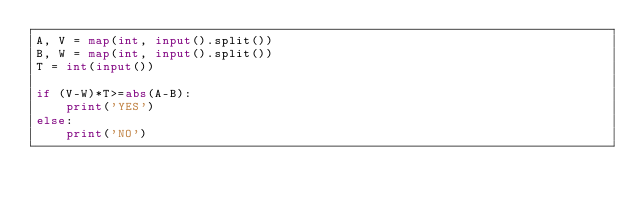<code> <loc_0><loc_0><loc_500><loc_500><_Python_>A, V = map(int, input().split())
B, W = map(int, input().split())
T = int(input())

if (V-W)*T>=abs(A-B):
    print('YES')
else:
    print('NO')</code> 